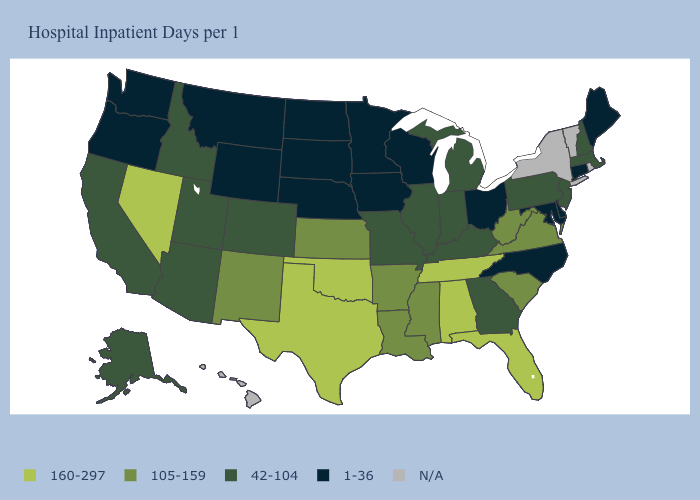What is the value of Montana?
Keep it brief. 1-36. Name the states that have a value in the range N/A?
Write a very short answer. Hawaii, New York, Rhode Island, Vermont. What is the value of Alaska?
Be succinct. 42-104. Is the legend a continuous bar?
Concise answer only. No. Does South Carolina have the highest value in the USA?
Answer briefly. No. Which states have the lowest value in the USA?
Answer briefly. Connecticut, Delaware, Iowa, Maine, Maryland, Minnesota, Montana, Nebraska, North Carolina, North Dakota, Ohio, Oregon, South Dakota, Washington, Wisconsin, Wyoming. Among the states that border Texas , does Arkansas have the lowest value?
Be succinct. Yes. What is the value of Delaware?
Be succinct. 1-36. What is the value of Utah?
Concise answer only. 42-104. Among the states that border Mississippi , which have the lowest value?
Quick response, please. Arkansas, Louisiana. Among the states that border Mississippi , does Tennessee have the lowest value?
Be succinct. No. Name the states that have a value in the range N/A?
Quick response, please. Hawaii, New York, Rhode Island, Vermont. What is the value of Vermont?
Short answer required. N/A. 